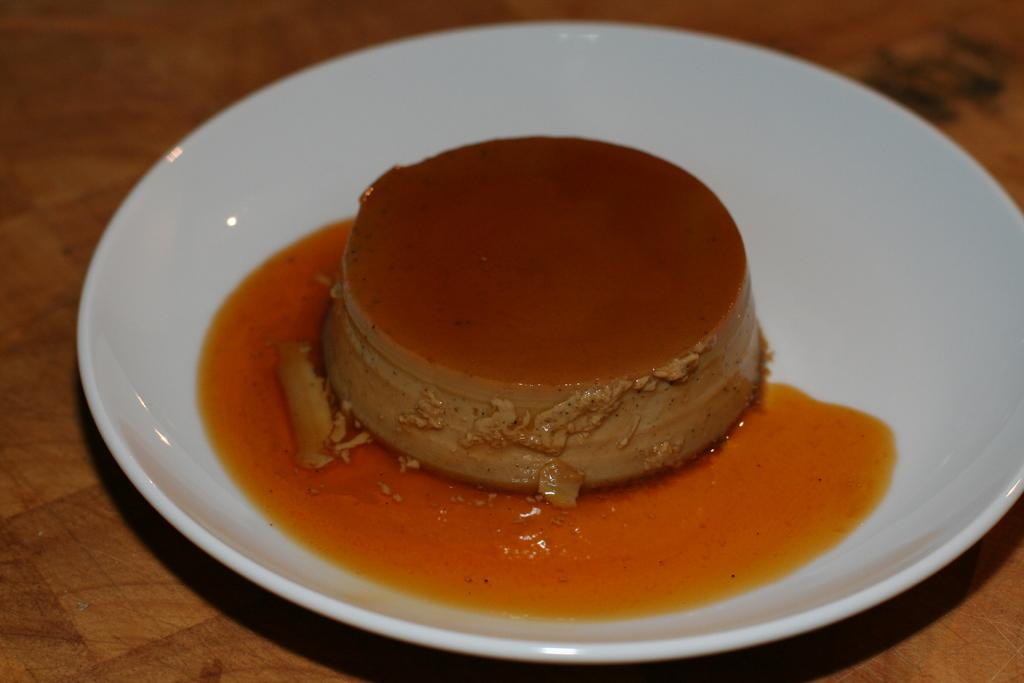What is on the plate that is visible in the image? There is a food item on a plate in the image. Where is the plate located? The plate is on a table. What type of box is being used to store the wrist in the image? There is no box or wrist present in the image; it only features a food item on a plate and a table. 